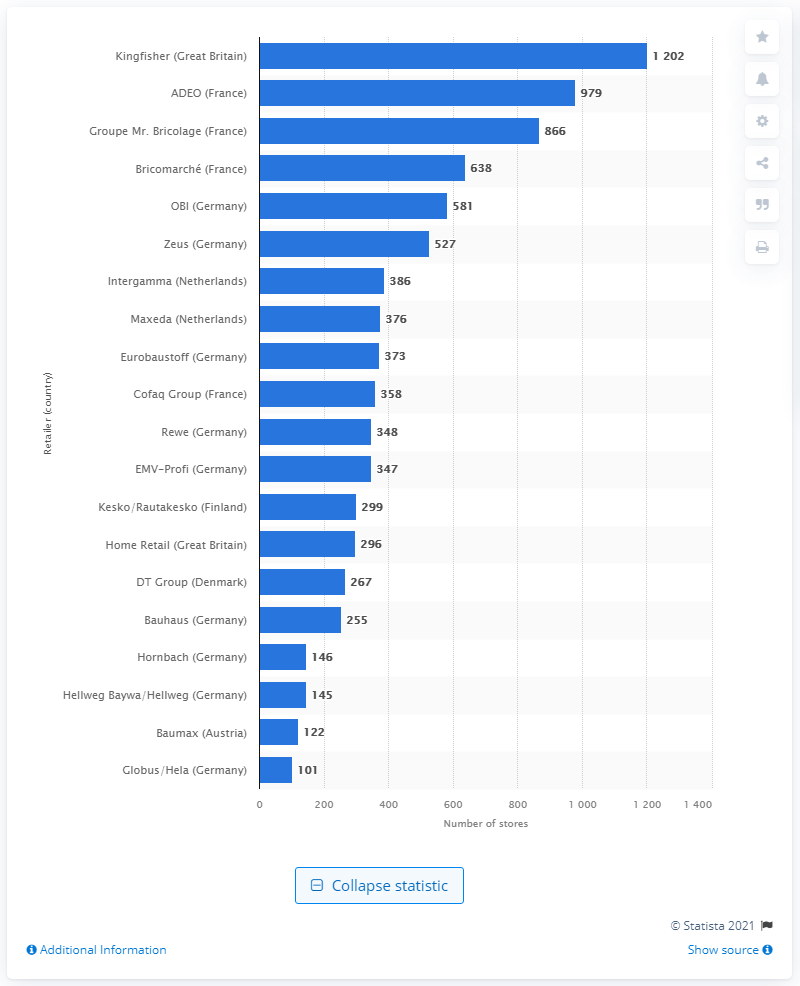What is the rank of Kingfisher in terms of the number of stores compared to other European retailers? Kingfisher ranks as the number one retailer in Europe in terms of the number of stores, leading the chart with 1,202 stores. 